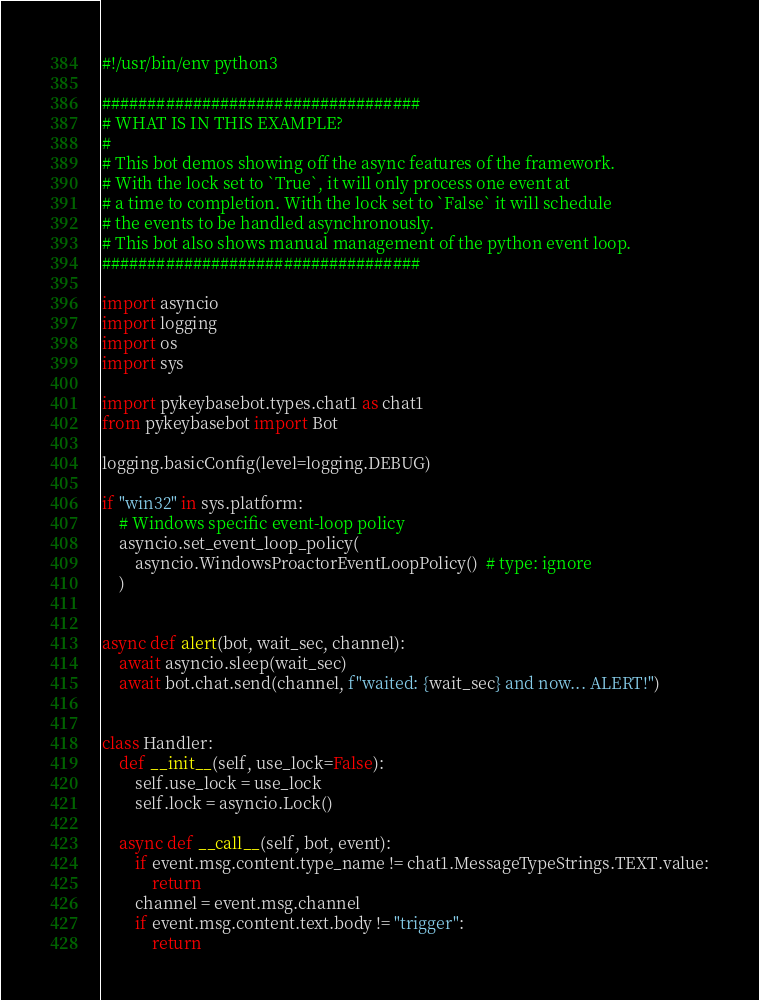Convert code to text. <code><loc_0><loc_0><loc_500><loc_500><_Python_>#!/usr/bin/env python3

###################################
# WHAT IS IN THIS EXAMPLE?
#
# This bot demos showing off the async features of the framework.
# With the lock set to `True`, it will only process one event at
# a time to completion. With the lock set to `False` it will schedule
# the events to be handled asynchronously.
# This bot also shows manual management of the python event loop.
###################################

import asyncio
import logging
import os
import sys

import pykeybasebot.types.chat1 as chat1
from pykeybasebot import Bot

logging.basicConfig(level=logging.DEBUG)

if "win32" in sys.platform:
    # Windows specific event-loop policy
    asyncio.set_event_loop_policy(
        asyncio.WindowsProactorEventLoopPolicy()  # type: ignore
    )


async def alert(bot, wait_sec, channel):
    await asyncio.sleep(wait_sec)
    await bot.chat.send(channel, f"waited: {wait_sec} and now... ALERT!")


class Handler:
    def __init__(self, use_lock=False):
        self.use_lock = use_lock
        self.lock = asyncio.Lock()

    async def __call__(self, bot, event):
        if event.msg.content.type_name != chat1.MessageTypeStrings.TEXT.value:
            return
        channel = event.msg.channel
        if event.msg.content.text.body != "trigger":
            return</code> 